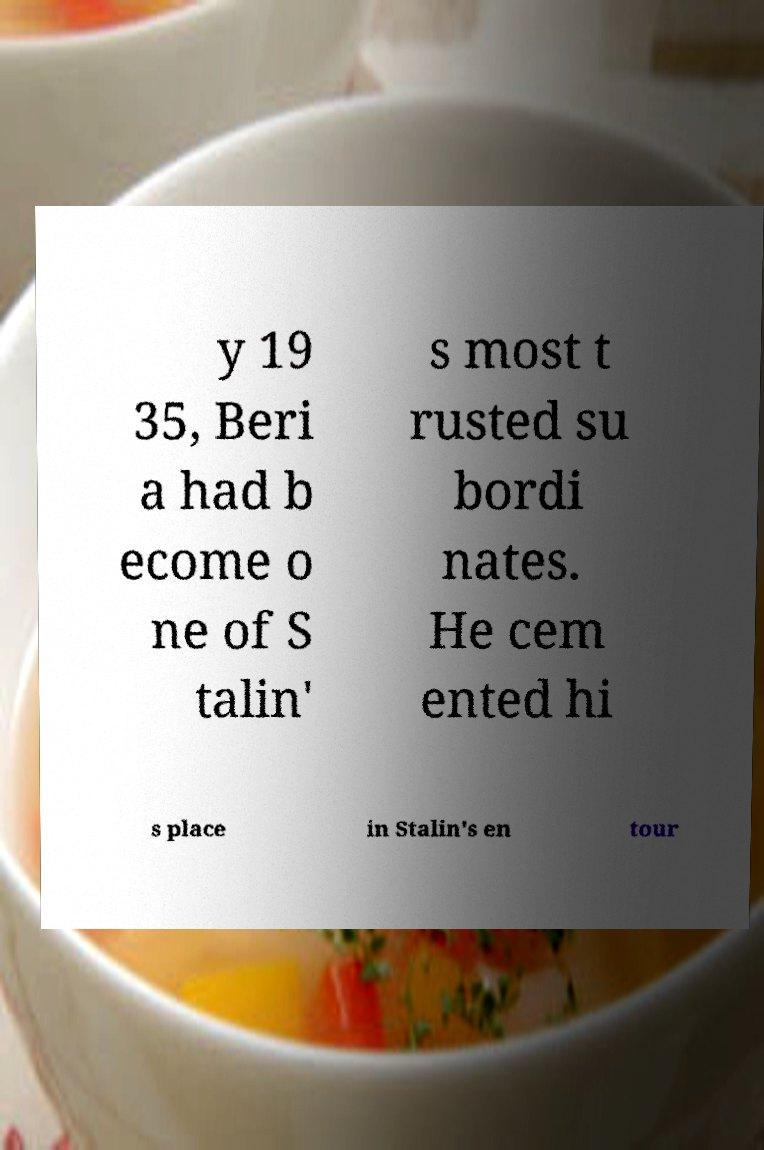There's text embedded in this image that I need extracted. Can you transcribe it verbatim? y 19 35, Beri a had b ecome o ne of S talin' s most t rusted su bordi nates. He cem ented hi s place in Stalin's en tour 